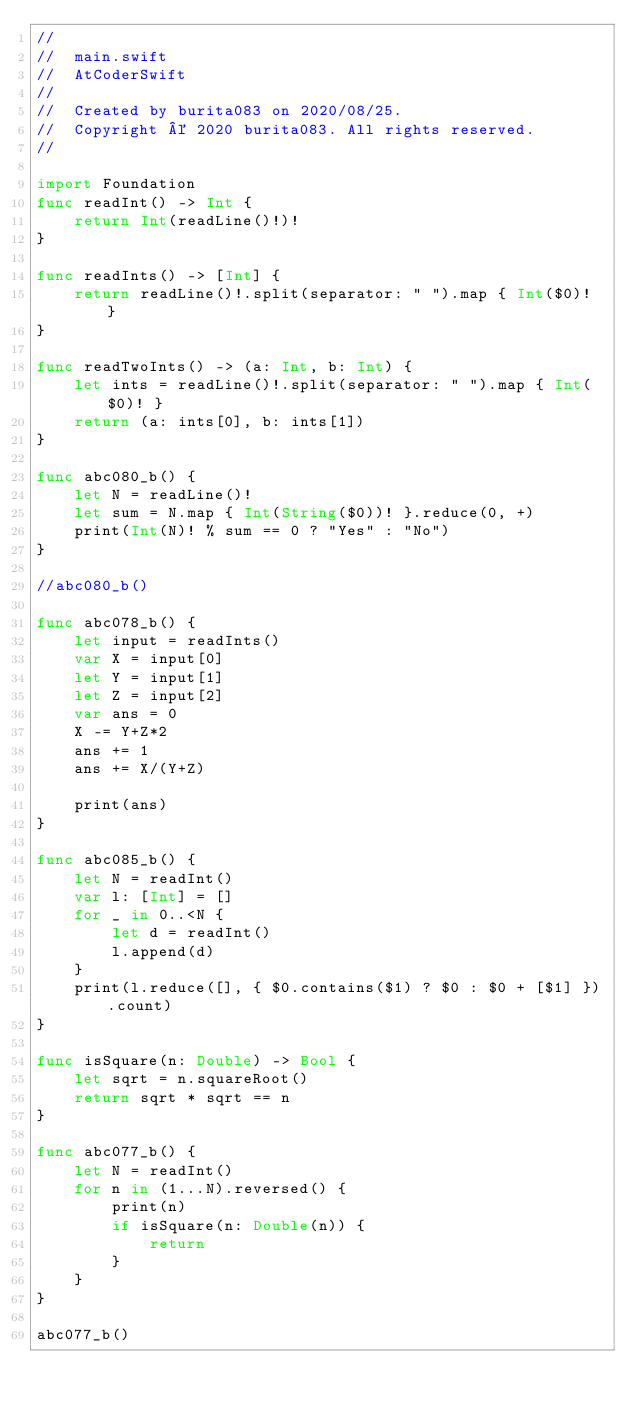<code> <loc_0><loc_0><loc_500><loc_500><_Swift_>//
//  main.swift
//  AtCoderSwift
//
//  Created by burita083 on 2020/08/25.
//  Copyright © 2020 burita083. All rights reserved.
//

import Foundation
func readInt() -> Int {
    return Int(readLine()!)!
}
 
func readInts() -> [Int] {
    return readLine()!.split(separator: " ").map { Int($0)! }
}
 
func readTwoInts() -> (a: Int, b: Int) {
    let ints = readLine()!.split(separator: " ").map { Int($0)! }
    return (a: ints[0], b: ints[1])
}

func abc080_b() {
    let N = readLine()!
    let sum = N.map { Int(String($0))! }.reduce(0, +)
    print(Int(N)! % sum == 0 ? "Yes" : "No")
}

//abc080_b()

func abc078_b() {
    let input = readInts()
    var X = input[0]
    let Y = input[1]
    let Z = input[2]
    var ans = 0
    X -= Y+Z*2
    ans += 1
    ans += X/(Y+Z)
    
    print(ans)
}

func abc085_b() {
    let N = readInt()
    var l: [Int] = []
    for _ in 0..<N {
        let d = readInt()
        l.append(d)
    }
    print(l.reduce([], { $0.contains($1) ? $0 : $0 + [$1] }).count)
}

func isSquare(n: Double) -> Bool {
    let sqrt = n.squareRoot()
    return sqrt * sqrt == n
}

func abc077_b() {
    let N = readInt()
    for n in (1...N).reversed() {
        print(n)
        if isSquare(n: Double(n)) {
            return
        }
    }
}

abc077_b()

</code> 